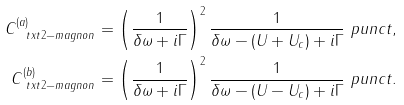Convert formula to latex. <formula><loc_0><loc_0><loc_500><loc_500>C ^ { ( a ) } _ { \ t x t { 2 - m a g n o n } } & = \left ( \frac { 1 } { \delta \omega + i \Gamma } \right ) ^ { 2 } \frac { 1 } { \delta \omega - ( U + U _ { c } ) + i \Gamma } \ p u n c t { , } \\ C ^ { ( b ) } _ { \ t x t { 2 - m a g n o n } } & = \left ( \frac { 1 } { \delta \omega + i \Gamma } \right ) ^ { 2 } \frac { 1 } { \delta \omega - ( U - U _ { c } ) + i \Gamma } \ p u n c t { . }</formula> 